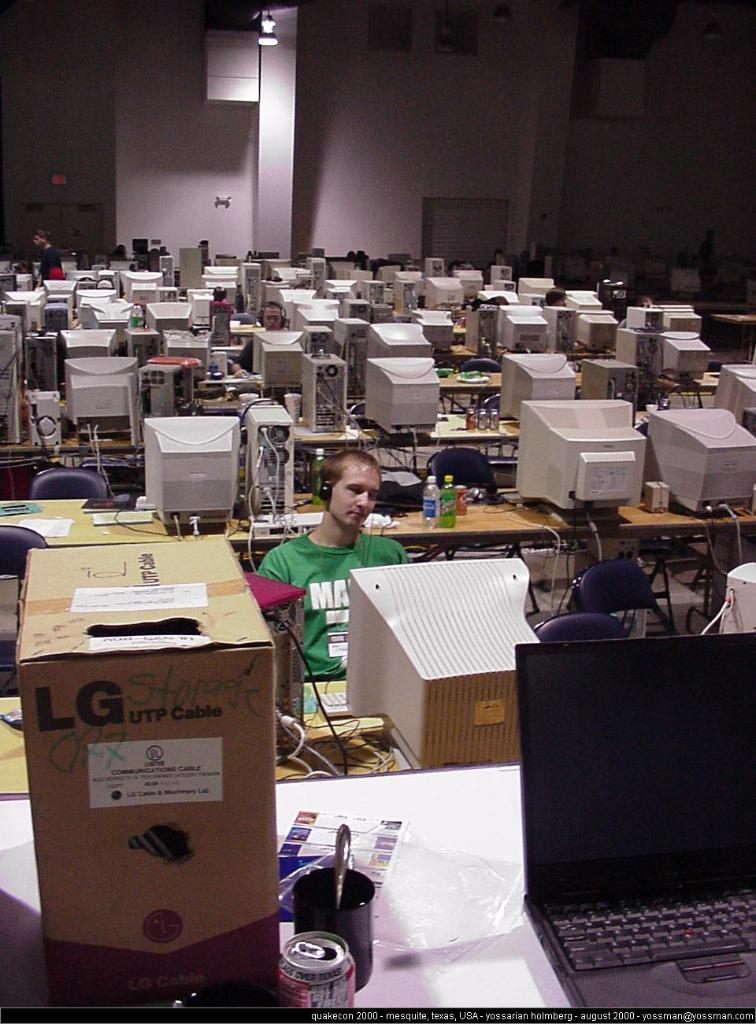<image>
Present a compact description of the photo's key features. A cardboard LG UTP Cable box is on the closest table in a room filled with computers and a few people. 